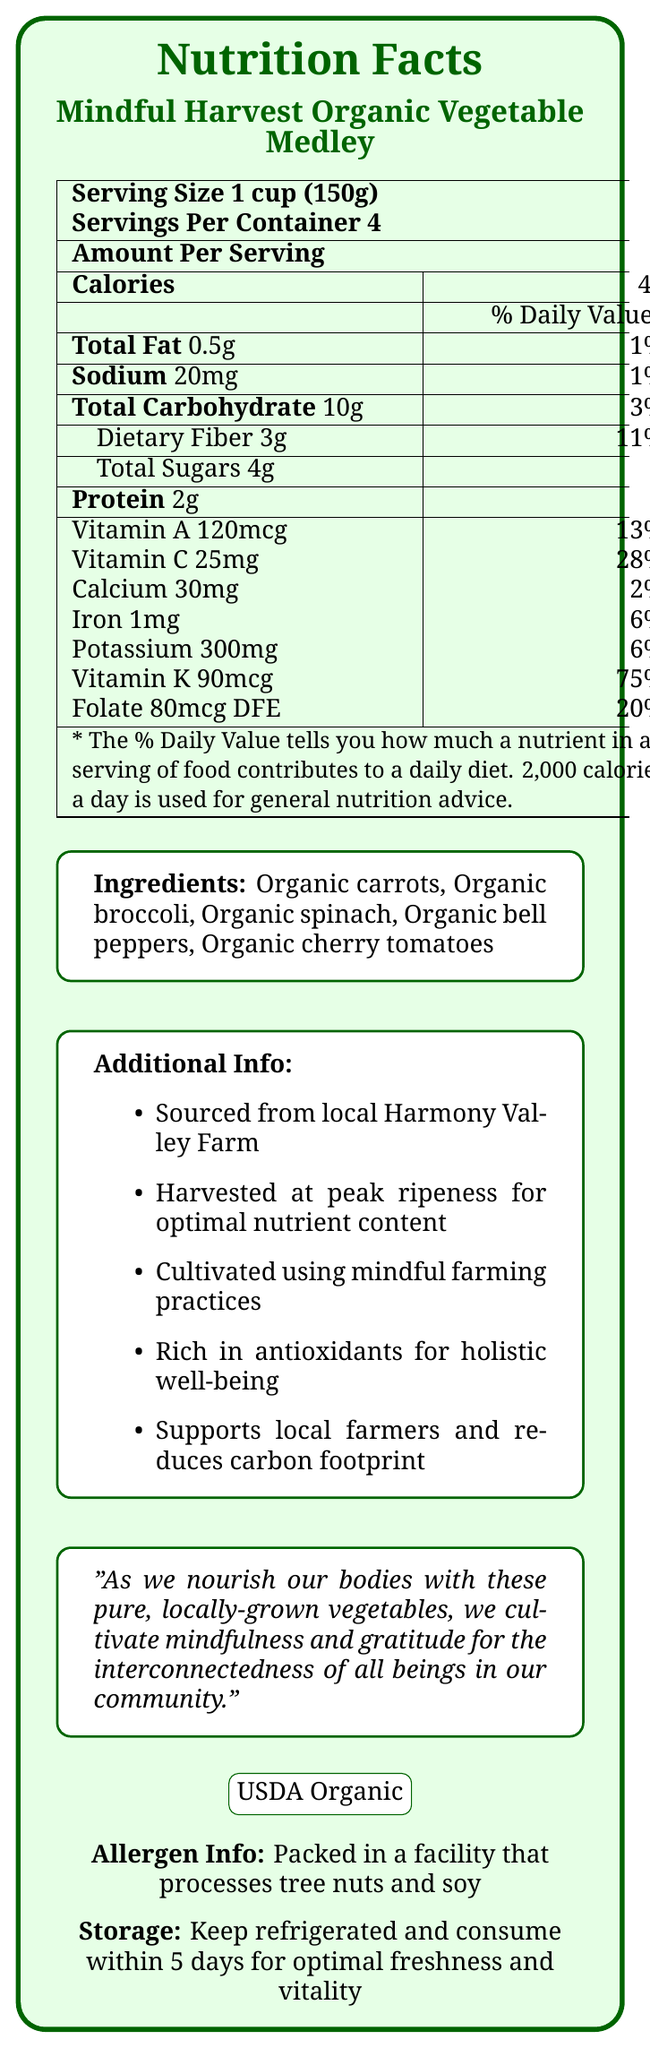what is the serving size of Mindful Harvest Organic Vegetable Medley? The serving size is directly stated in the document under the product name.
Answer: 1 cup (150g) How many servings are there per container? The document specifies that there are 4 servings per container.
Answer: 4 what is the amount of calories per serving? The calories per serving are listed as 45 in the document.
Answer: 45 What is the total fat content per serving? The document lists the total fat content as 0.5g per serving.
Answer: 0.5g Which ingredient provides the most vitamin K per serving? Although the document does not explicitly link vitamins to specific ingredients, spinach is generally high in vitamin K.
Answer: Organic spinach What percentage of the daily value of Vitamin C does one serving provide? A. 13% B. 28% C. 6% D. 75% The document states that one serving provides 28% of the daily value of Vitamin C.
Answer: B Which vitamins are mentioned in the nutrition facts of the document? I. Vitamin A II. Vitamin C III. Vitamin K IV. Folate The document mentions all four vitamins.
Answer: I, II, III, and IV Are the vegetables sourced locally? The document mentions that the vegetables are sourced from local Harmony Valley Farm.
Answer: Yes Summarize the main idea of the document. The summary captures key points including the product's nutritional details, sourcing, and cultivation practices.
Answer: The document provides the nutrition facts for Mindful Harvest Organic Vegetable Medley, emphasizing its organic, locally-sourced ingredients, rich vitamin and mineral content, and the mindful farming practices used. What is the brand of the vegetable medley? The document always refers to the product name as "Mindful Harvest Organic Vegetable Medley," but it does not label "Mindful Harvest" explicitly as a brand.
Answer: Cannot be determined What is the daily value percentage of dietary fiber per serving? The document lists dietary fiber as providing 11% of the daily value per serving.
Answer: 11% What is the recommended storage method for the vegetable medley? This information is stated toward the end of the document.
Answer: Keep refrigerated and consume within 5 days for optimal freshness and vitality What is the USDA Organic certification mentioned in the document? The document includes the USDA Organic certification to signify that the product adheres to organic farming guidelines.
Answer: It indicates that the product meets the USDA organic standards. How much sodium does one serving contain? The amount of sodium per serving is listed as 20mg.
Answer: 20mg What kind of nutrients contribute to holistic well-being according to the document? The document mentions that the vegetable medley is rich in antioxidants, which contribute to holistic well-being.
Answer: Antioxidants 